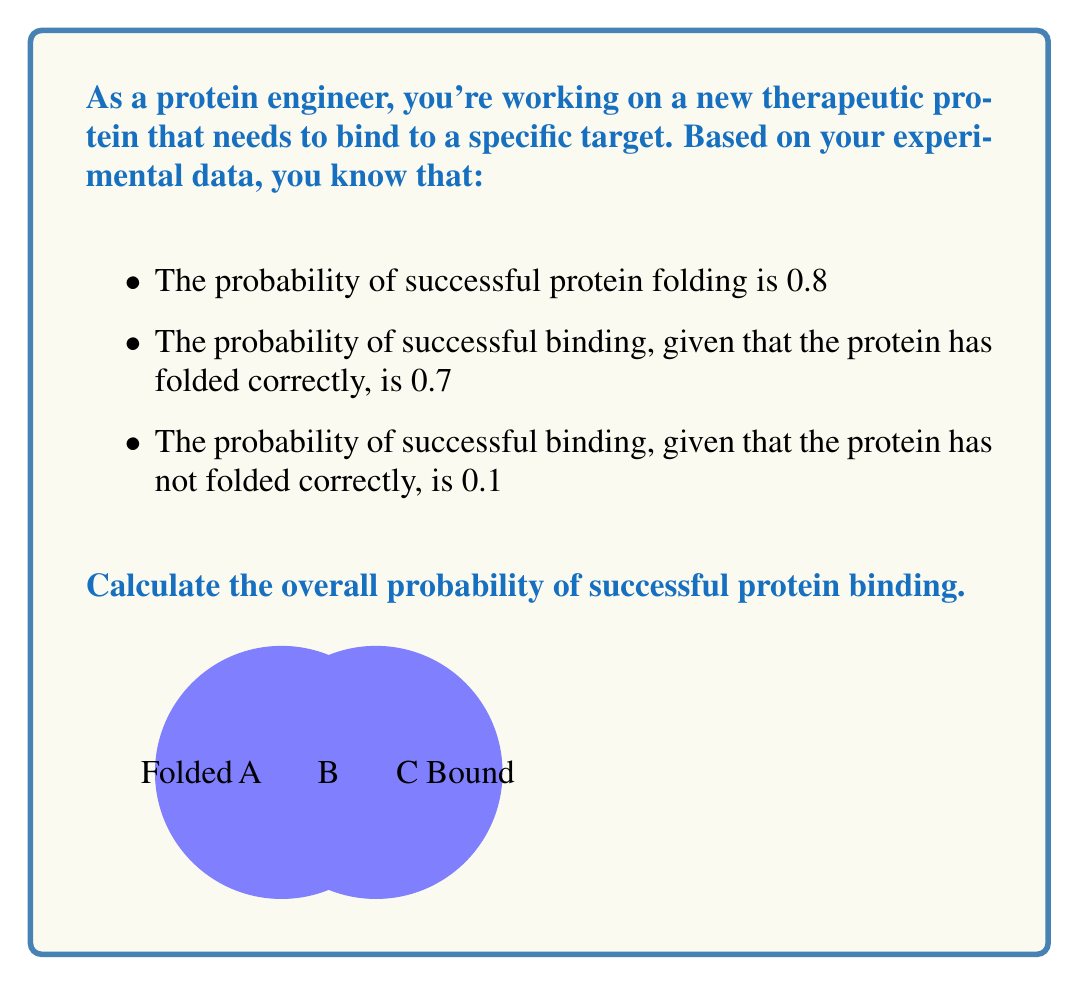Provide a solution to this math problem. Let's approach this step-by-step using conditional probability:

1) Let's define our events:
   F: Protein folds correctly
   B: Protein binds successfully

2) We're given:
   $P(F) = 0.8$
   $P(B|F) = 0.7$
   $P(B|\text{not }F) = 0.1$

3) We want to find $P(B)$. We can use the law of total probability:

   $P(B) = P(B|F) \cdot P(F) + P(B|\text{not }F) \cdot P(\text{not }F)$

4) We know $P(F) = 0.8$, so $P(\text{not }F) = 1 - P(F) = 0.2$

5) Now let's substitute all known values:

   $P(B) = 0.7 \cdot 0.8 + 0.1 \cdot 0.2$

6) Calculate:
   $P(B) = 0.56 + 0.02 = 0.58$

Therefore, the overall probability of successful protein binding is 0.58 or 58%.
Answer: $0.58$ 